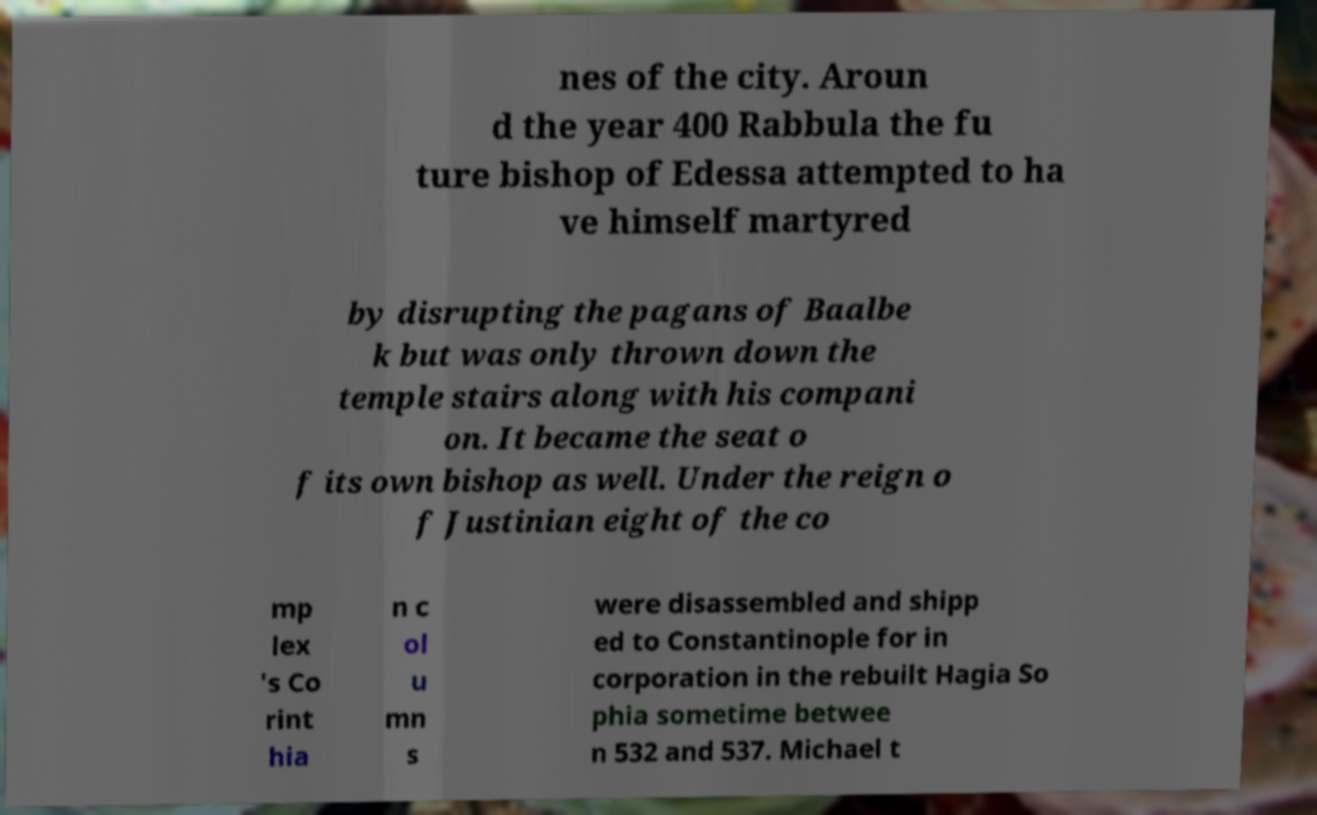Could you assist in decoding the text presented in this image and type it out clearly? nes of the city. Aroun d the year 400 Rabbula the fu ture bishop of Edessa attempted to ha ve himself martyred by disrupting the pagans of Baalbe k but was only thrown down the temple stairs along with his compani on. It became the seat o f its own bishop as well. Under the reign o f Justinian eight of the co mp lex 's Co rint hia n c ol u mn s were disassembled and shipp ed to Constantinople for in corporation in the rebuilt Hagia So phia sometime betwee n 532 and 537. Michael t 